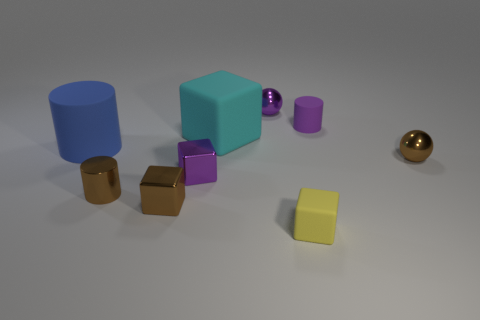Are the sphere that is in front of the blue matte cylinder and the big blue thing made of the same material?
Give a very brief answer. No. What color is the tiny cube that is made of the same material as the blue cylinder?
Ensure brevity in your answer.  Yellow. There is a small shiny ball that is right of the yellow object; is it the same color as the small cylinder left of the big cyan rubber object?
Provide a succinct answer. Yes. How many blocks are big matte things or yellow rubber things?
Your response must be concise. 2. Are there an equal number of yellow matte things in front of the yellow thing and small shiny things?
Give a very brief answer. No. What is the tiny brown object in front of the small cylinder to the left of the matte thing in front of the blue rubber cylinder made of?
Ensure brevity in your answer.  Metal. How many objects are big objects behind the blue cylinder or blue rubber objects?
Provide a short and direct response. 2. How many objects are either brown cylinders or small shiny balls behind the small brown metallic sphere?
Provide a succinct answer. 2. How many big blue matte objects are on the left side of the shiny block that is in front of the tiny cylinder that is on the left side of the small purple shiny ball?
Ensure brevity in your answer.  1. What is the material of the cyan cube that is the same size as the blue matte cylinder?
Your answer should be very brief. Rubber. 